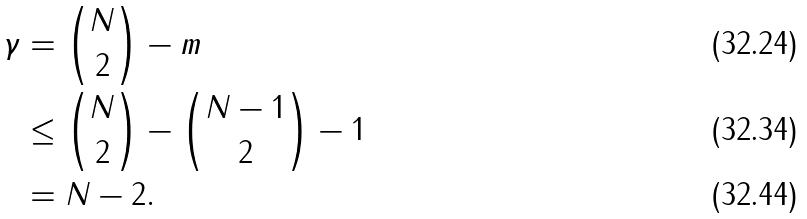Convert formula to latex. <formula><loc_0><loc_0><loc_500><loc_500>\gamma & = { N \choose 2 } - m \\ & \leq { N \choose 2 } - { N - 1 \choose 2 } - 1 \\ & = N - 2 .</formula> 